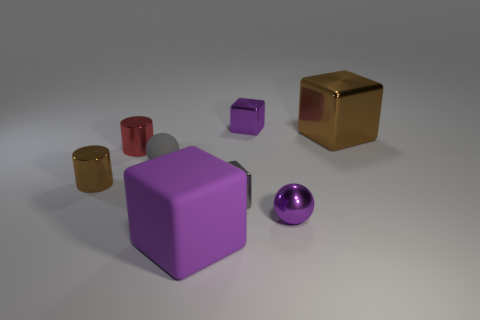How many other things are there of the same color as the big metallic block?
Provide a succinct answer. 1. What size is the block that is the same color as the matte sphere?
Provide a succinct answer. Small. How many objects are either large yellow matte cylinders or brown blocks?
Make the answer very short. 1. What is the gray thing to the right of the purple block that is in front of the tiny shiny sphere made of?
Your answer should be compact. Metal. Is there a big matte object of the same color as the big metal block?
Offer a very short reply. No. What is the color of the rubber sphere that is the same size as the metal ball?
Keep it short and to the point. Gray. The purple block in front of the tiny purple sphere in front of the large brown metal thing behind the small gray matte sphere is made of what material?
Offer a terse response. Rubber. Does the big metal thing have the same color as the small shiny cylinder that is in front of the gray rubber thing?
Provide a short and direct response. Yes. What number of things are either brown metal objects that are behind the small red metallic thing or blocks behind the gray matte ball?
Provide a short and direct response. 2. What shape is the big thing left of the gray object on the right side of the large purple object?
Your answer should be compact. Cube. 